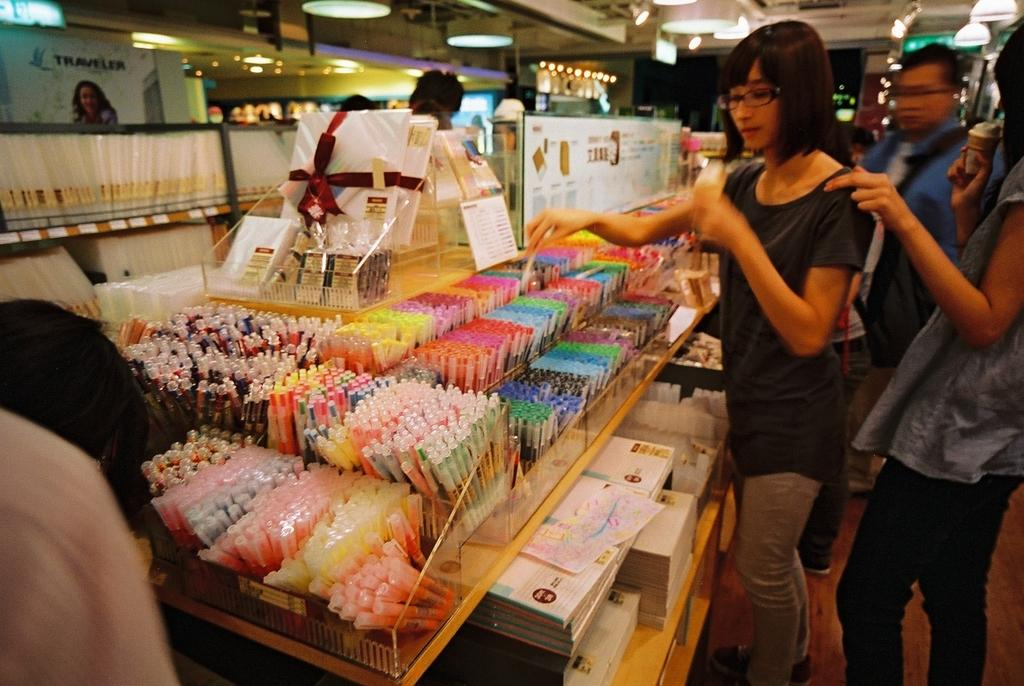How many people are in the image? There is a group of people in the image, but the exact number is not specified. What are the people doing in the image? The people are standing in the image. What objects are on the table in front of the people? There are pens and books on the table in front of the people. What can be seen in the background of the image? There are lights visible in the background of the image. What type of pie is being served to the people in the image? There is no pie present in the image; the objects on the table are pens and books. 